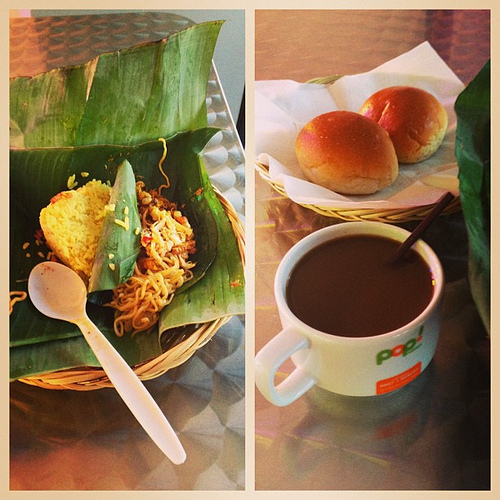What is the drink that the straw is in? The straw is immersed in a comforting mug of coffee, its deep brown color hinting at a rich, robust flavor. 